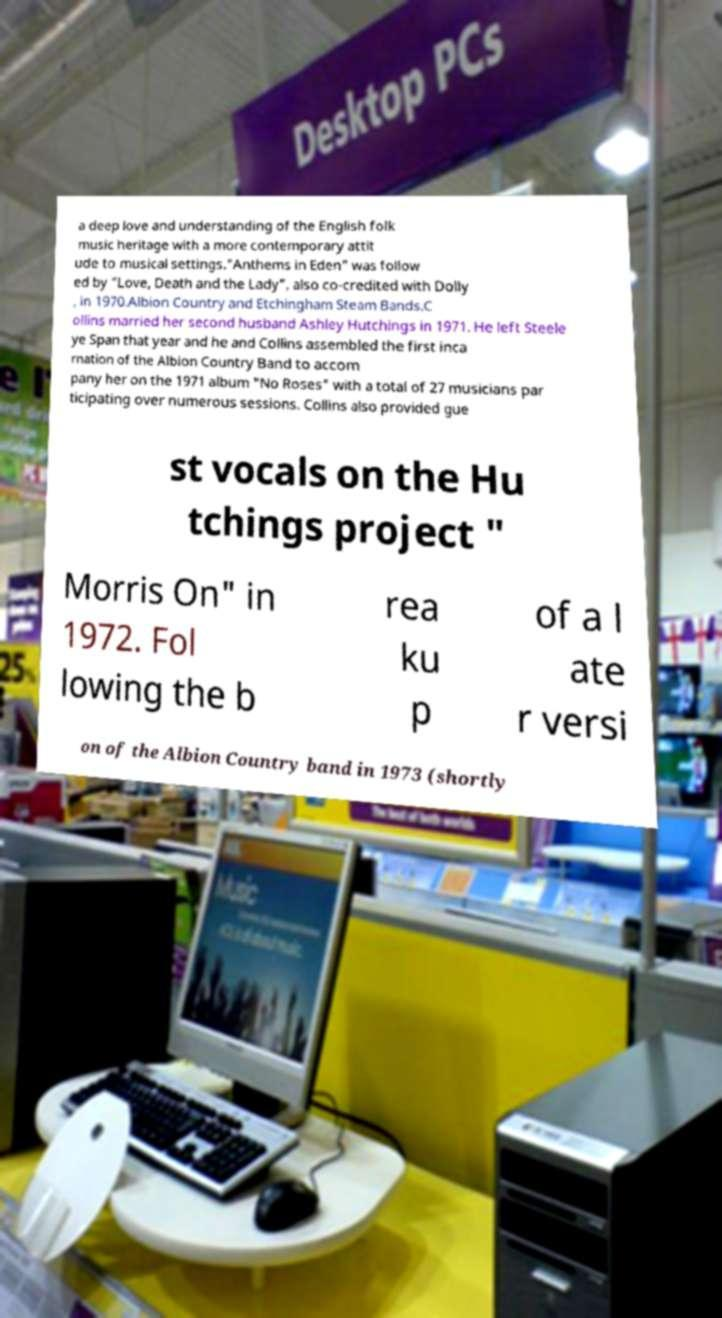For documentation purposes, I need the text within this image transcribed. Could you provide that? a deep love and understanding of the English folk music heritage with a more contemporary attit ude to musical settings."Anthems in Eden" was follow ed by "Love, Death and the Lady", also co-credited with Dolly , in 1970.Albion Country and Etchingham Steam Bands.C ollins married her second husband Ashley Hutchings in 1971. He left Steele ye Span that year and he and Collins assembled the first inca rnation of the Albion Country Band to accom pany her on the 1971 album "No Roses" with a total of 27 musicians par ticipating over numerous sessions. Collins also provided gue st vocals on the Hu tchings project " Morris On" in 1972. Fol lowing the b rea ku p of a l ate r versi on of the Albion Country band in 1973 (shortly 